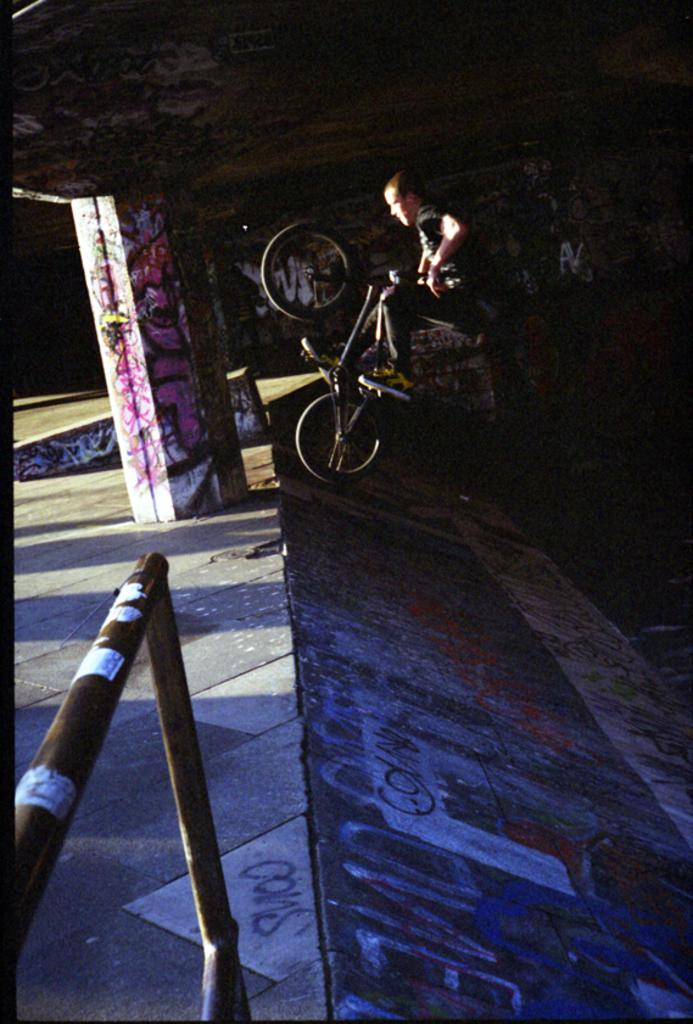What is the main subject of the image? There is a boy in the image. What is the boy doing in the image? The boy is performing a stunt with a bicycle. Where is the stunt being performed? The stunt is being performed on a slope. What type of fencing can be seen in the image? There is pipe fencing visible in the image. What is located in the middle of the image? There is a pillar in the middle of the image. What type of lock is the boy using to secure his bicycle in the image? There is no lock present in the image, as the boy is performing a stunt with the bicycle. What type of drink is the boy holding while performing the stunt in the image? There is no drink visible in the image; the boy is focused on performing the stunt with his bicycle. 